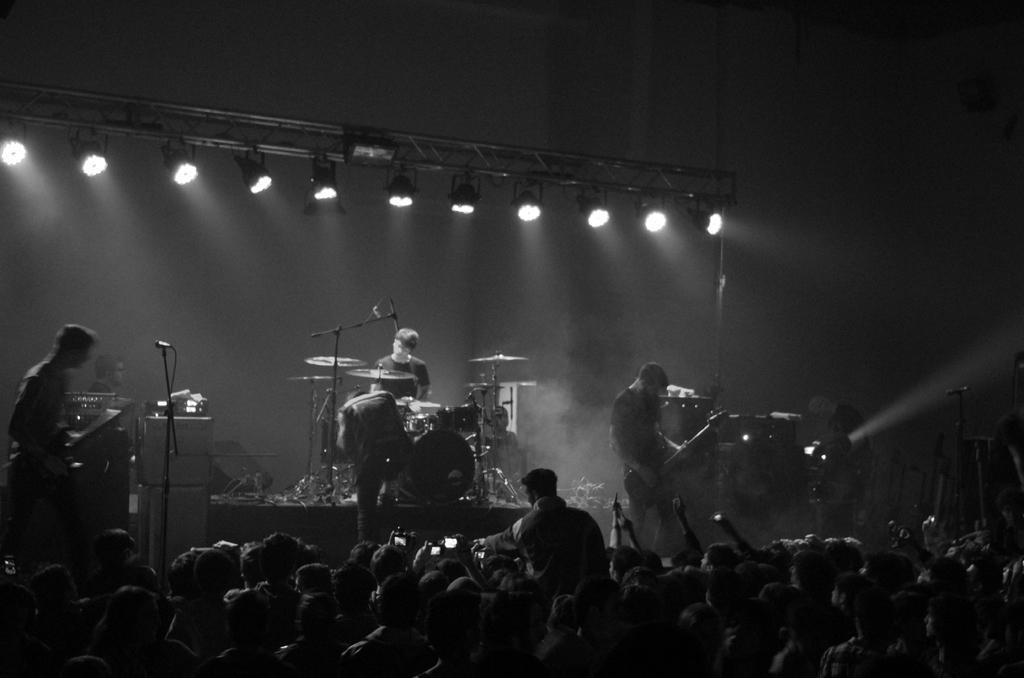Could you give a brief overview of what you see in this image? In this image there are group of people who are standing and on the stage there are some people who are standing. On the left side there is one man who is standing in front of him there is one mike. On the right side there is one person who is standing and he is holding a guitar. In the middle of the image there is one person who is standing and in front of him there are drums it seems that he is drumming on the top of the image there are some lights. 